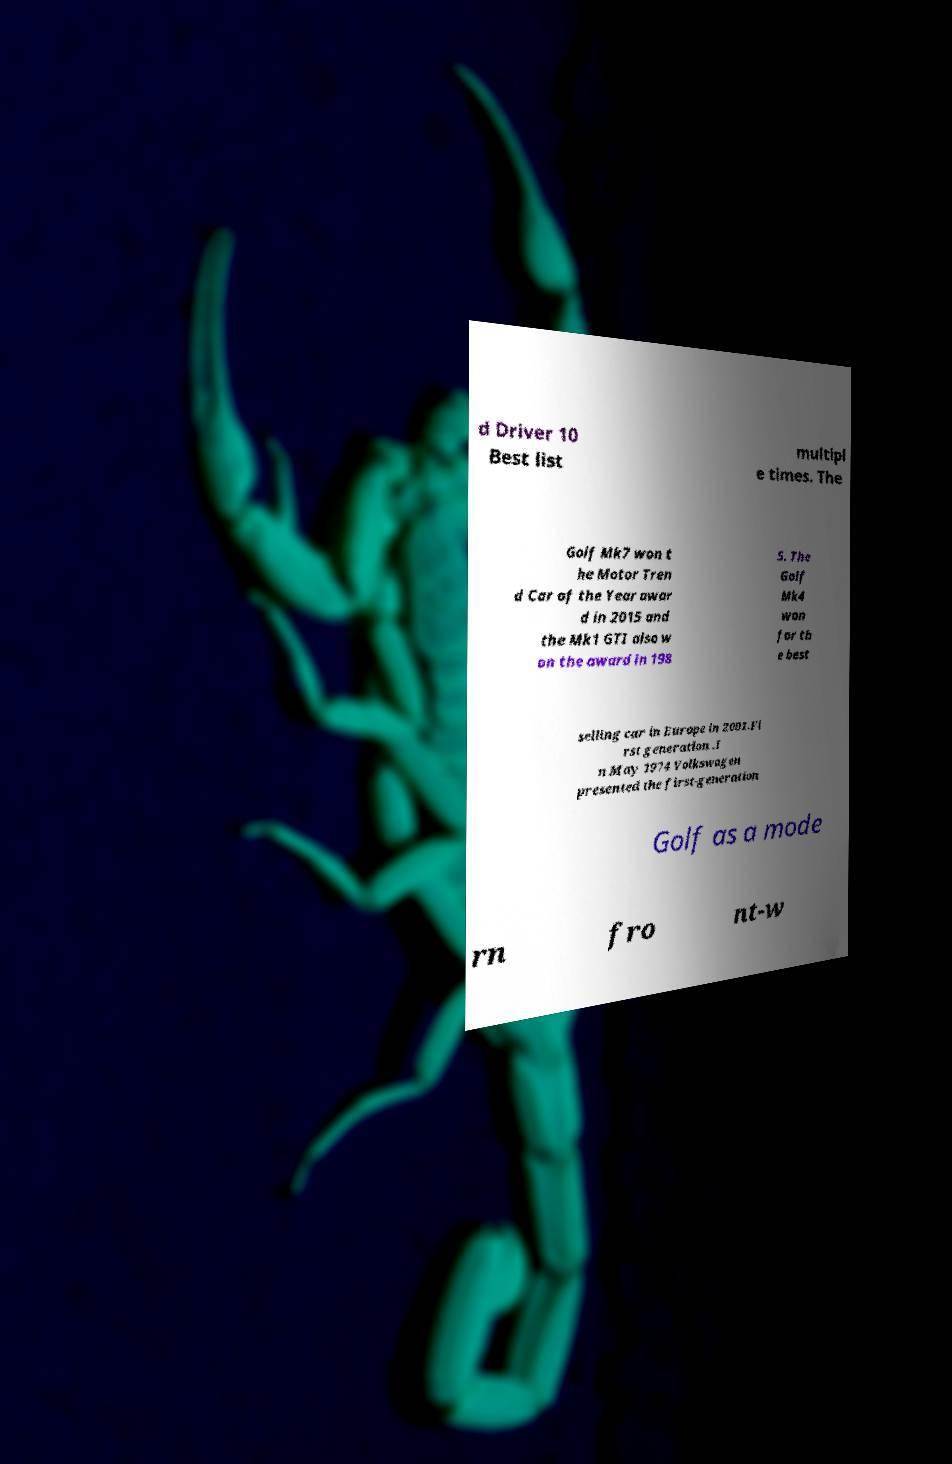Could you assist in decoding the text presented in this image and type it out clearly? d Driver 10 Best list multipl e times. The Golf Mk7 won t he Motor Tren d Car of the Year awar d in 2015 and the Mk1 GTI also w on the award in 198 5. The Golf Mk4 won for th e best selling car in Europe in 2001.Fi rst generation .I n May 1974 Volkswagen presented the first-generation Golf as a mode rn fro nt-w 